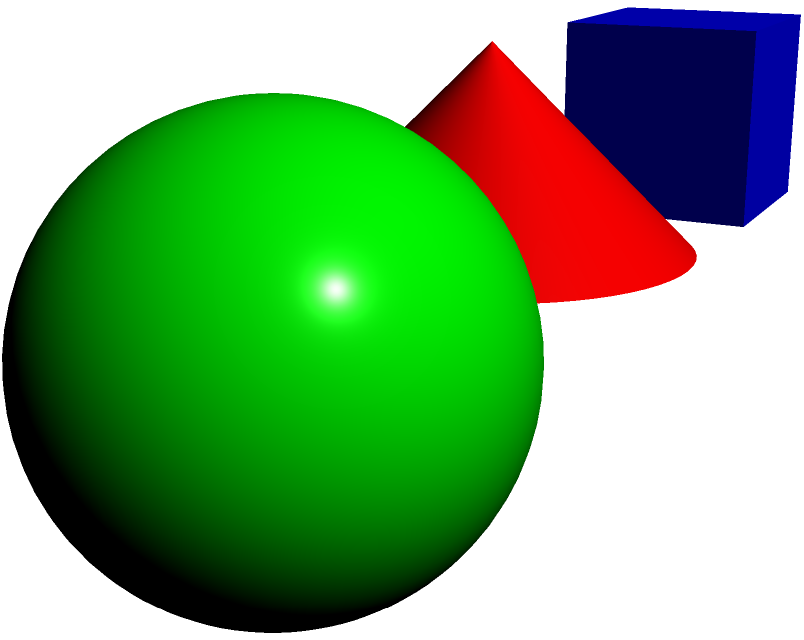Match the 3D objects (A, B, C) with their corresponding 2D shadows (1, 2, 3). Which combination is correct? To solve this problem, we need to analyze each 3D object and its potential 2D shadow:

1. Object A is a cube. When viewed from above, its shadow would be a square. This matches with shadow 1.

2. Object B is a cone. When viewed from above, its shadow would be a circle. This could match with either shadow 2 or 3.

3. Object C is a sphere. When viewed from above, its shadow would also be a circle. This could match with either shadow 2 or 3.

Since both the cone and sphere produce circular shadows, we need to consider their sizes:

4. The cone (Object B) has a wider base compared to its height, which would result in a larger circular shadow.

5. The sphere (Object C) would produce a circular shadow equal to its diameter, which appears smaller than the base of the cone in this image.

Therefore, the correct matching is:
- A (cube) corresponds to 1 (square shadow)
- B (cone) corresponds to 2 (larger circular shadow)
- C (sphere) corresponds to 3 (smaller circular shadow)
Answer: A-1, B-2, C-3 